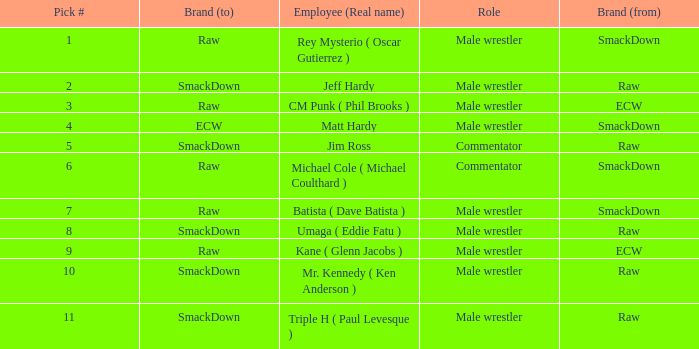Identify the real name of the male wrestler in raw who has a selection number under 6. Jeff Hardy. 